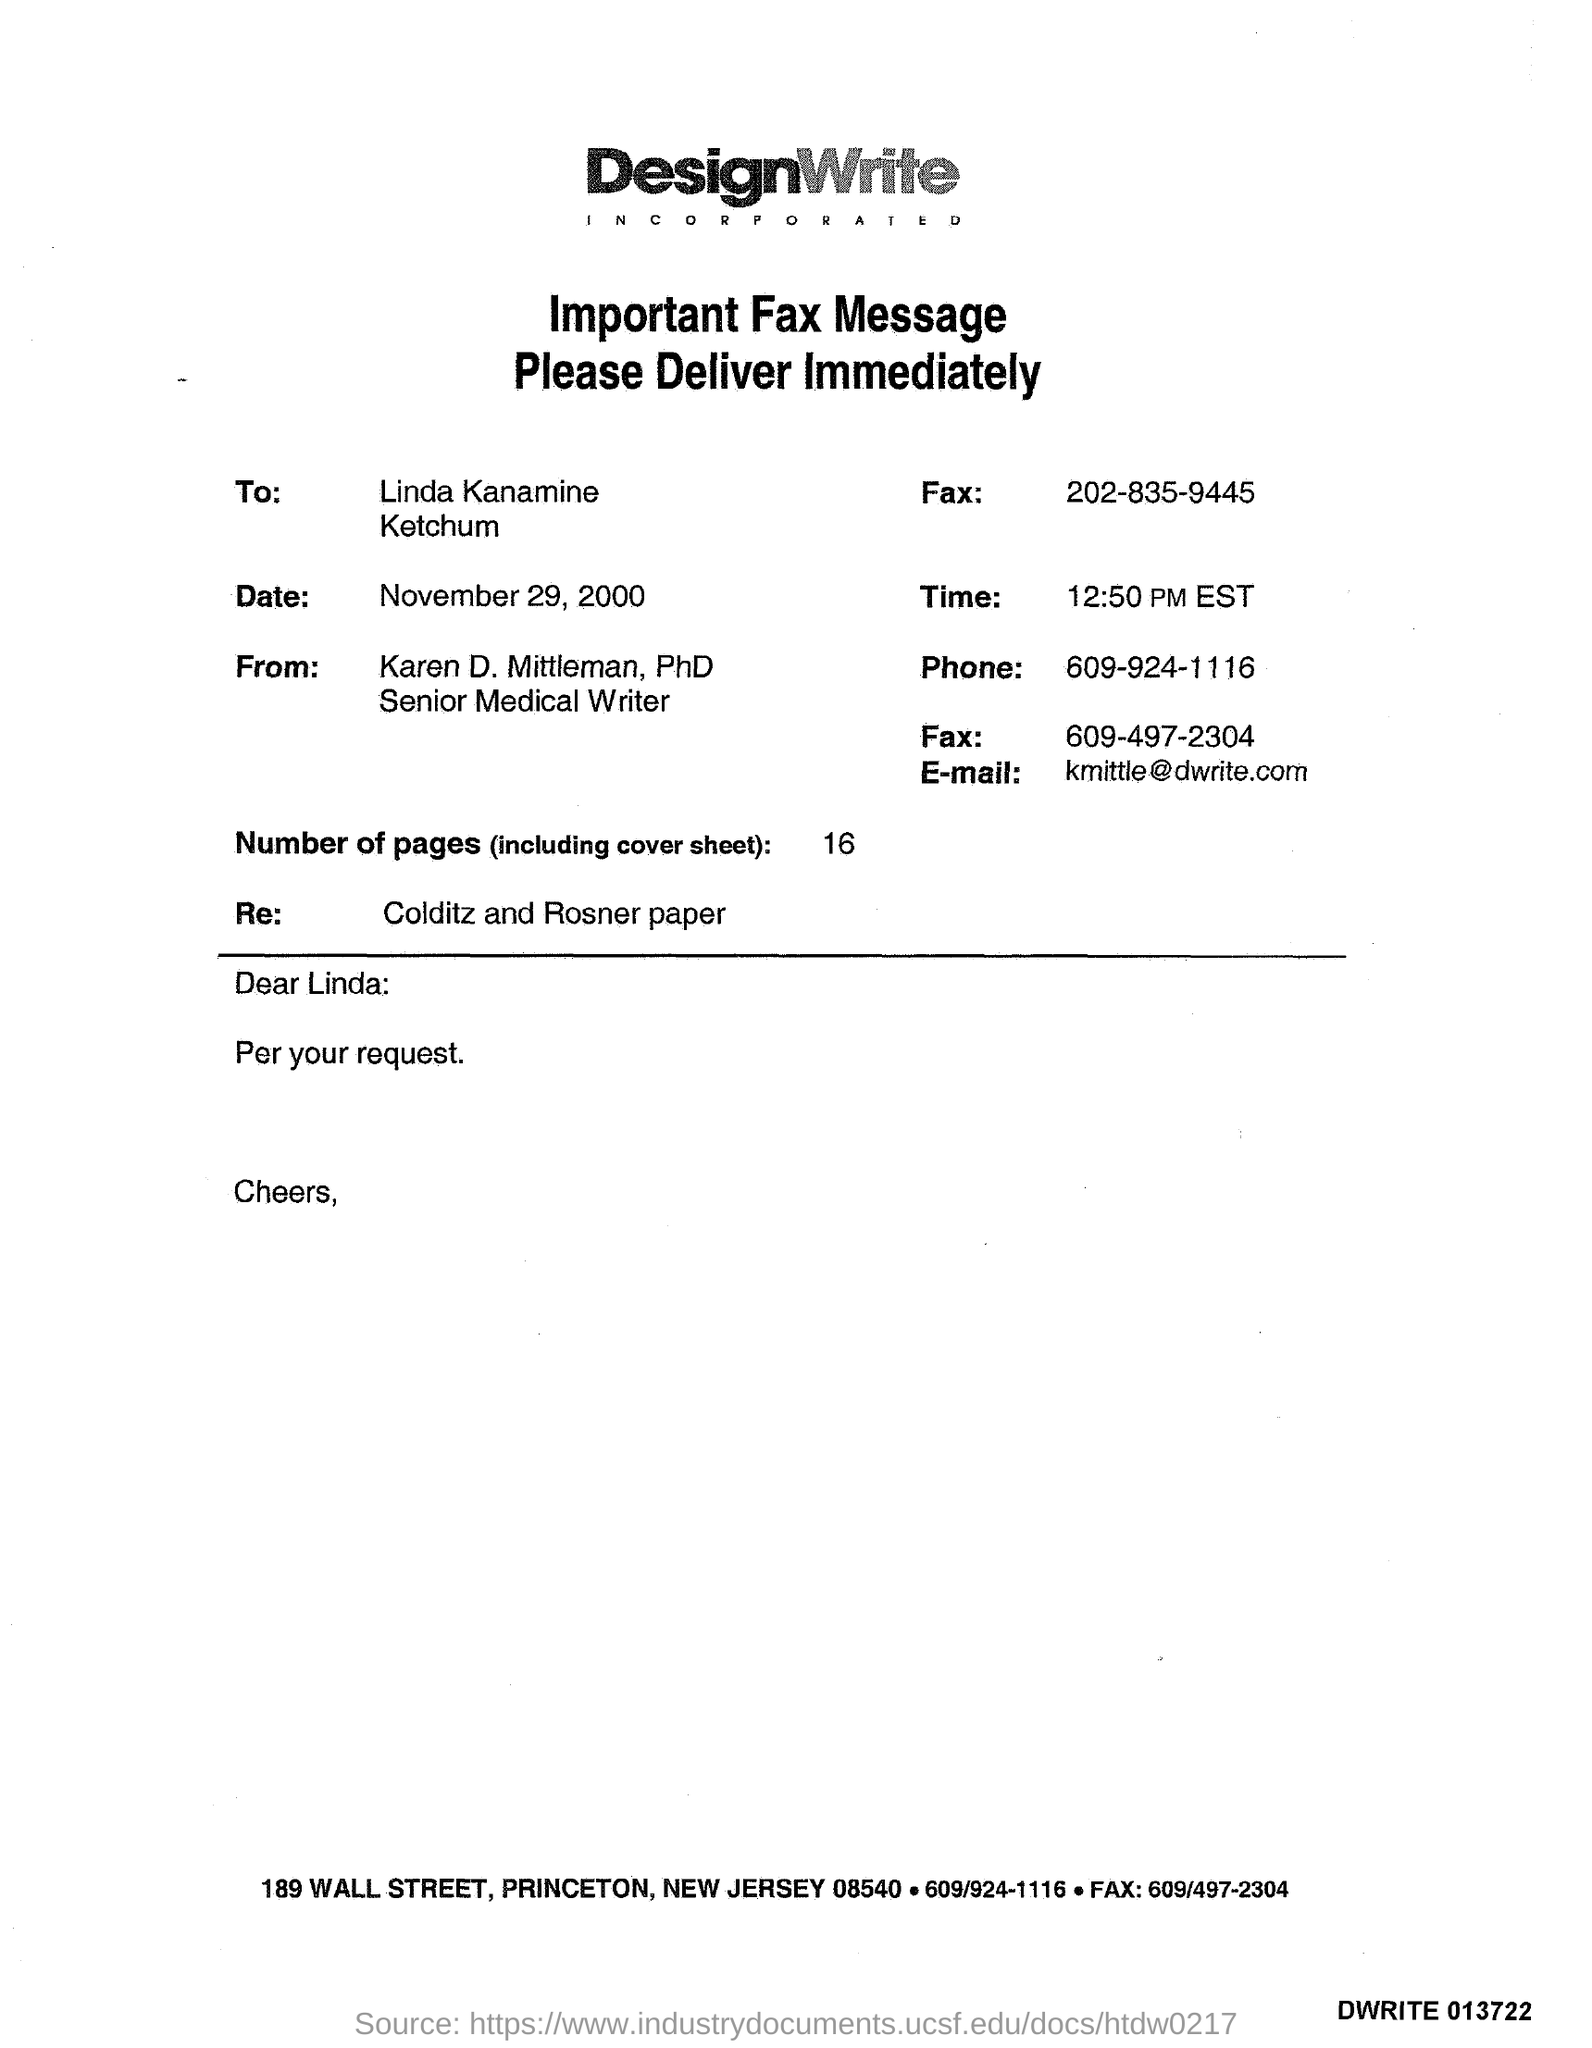List a handful of essential elements in this visual. It is currently 12:50 PM EST. The salutation of the letter is "Dear Linda:... The phone number is 609-924-1116. The E-mail address is [kmittle@dwrite.com](mailto:kmittle@dwrite.com). The date is November 29, 2000. 